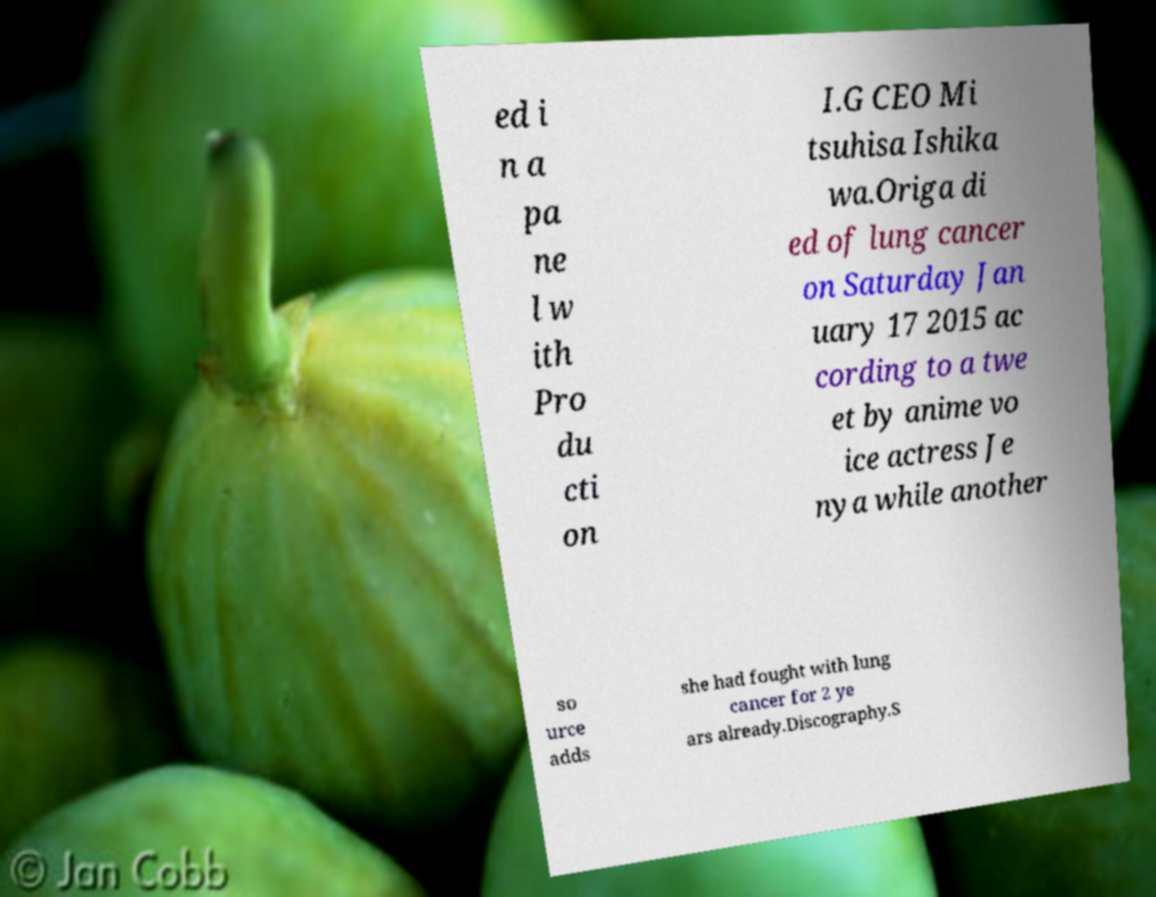For documentation purposes, I need the text within this image transcribed. Could you provide that? ed i n a pa ne l w ith Pro du cti on I.G CEO Mi tsuhisa Ishika wa.Origa di ed of lung cancer on Saturday Jan uary 17 2015 ac cording to a twe et by anime vo ice actress Je nya while another so urce adds she had fought with lung cancer for 2 ye ars already.Discography.S 